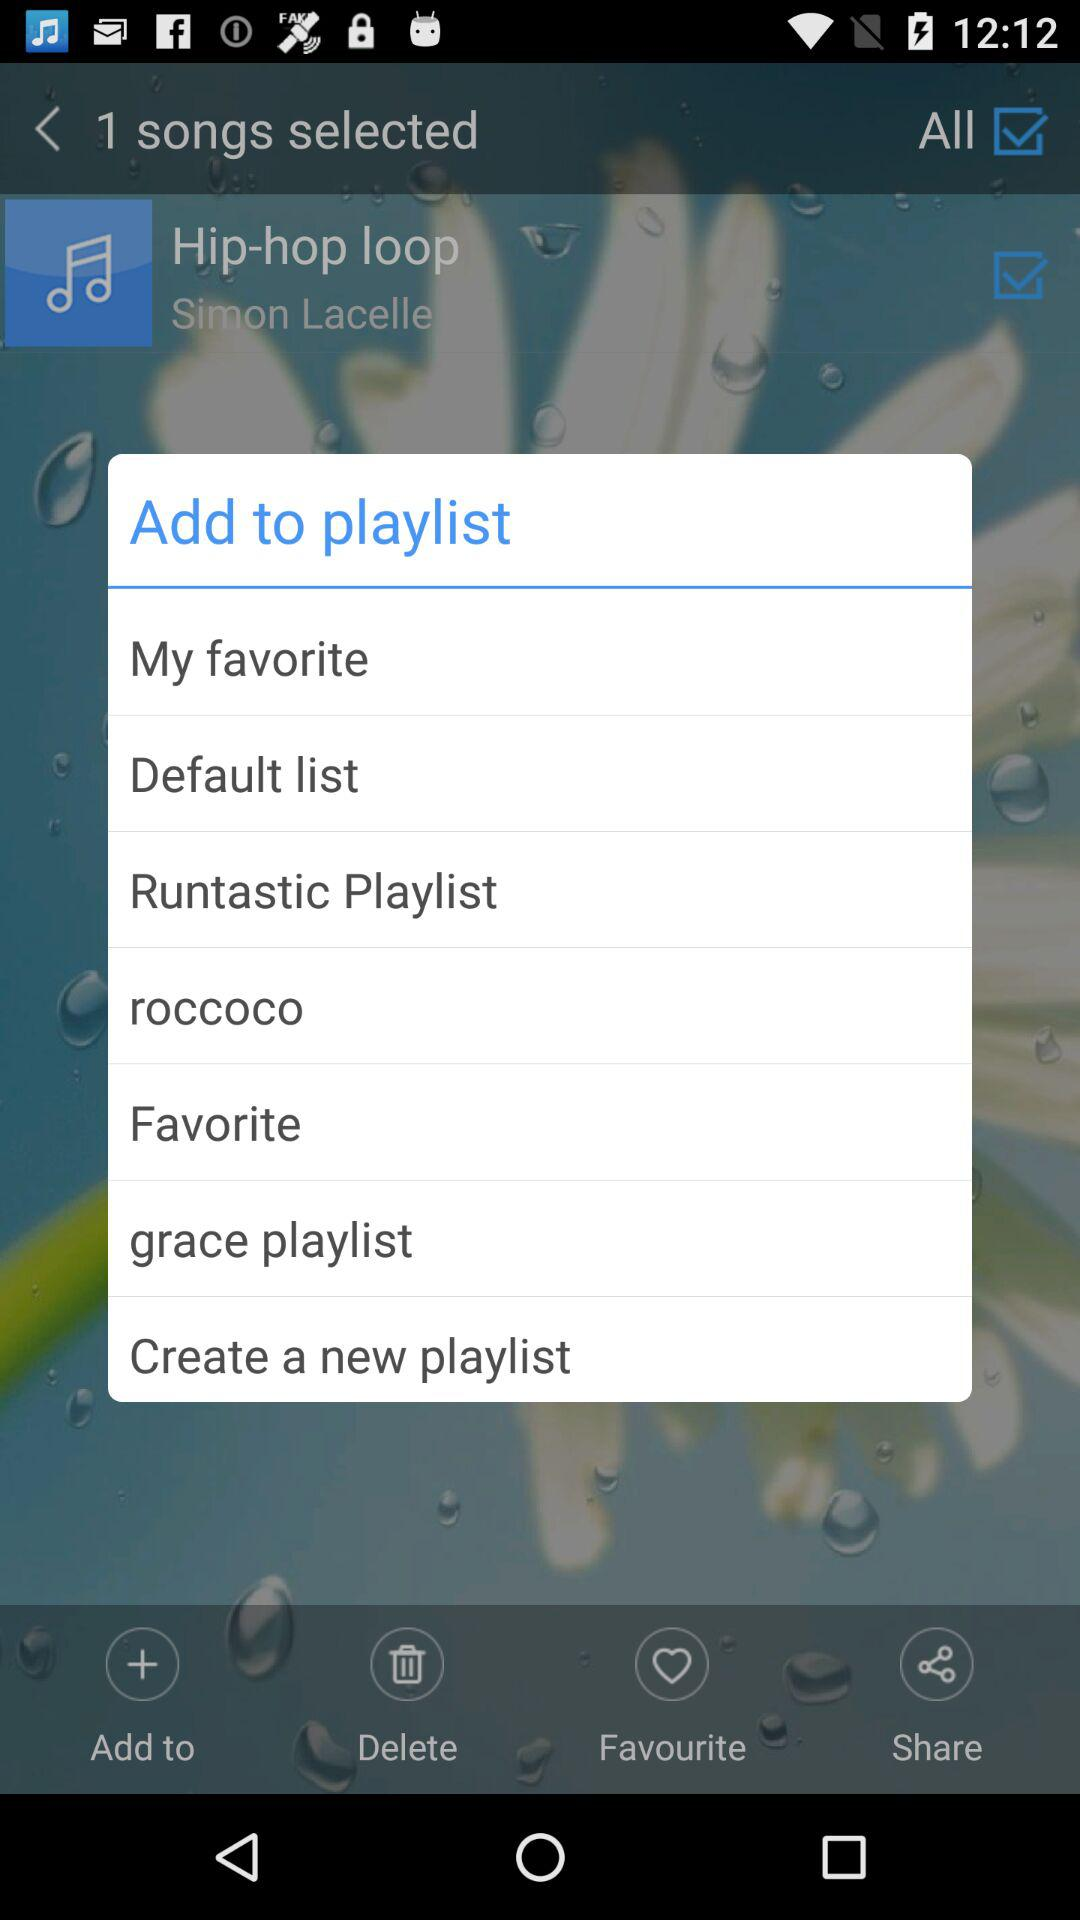How many songs are selected? The selected number of songs is 1. 